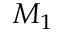Convert formula to latex. <formula><loc_0><loc_0><loc_500><loc_500>M _ { 1 }</formula> 